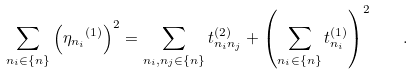Convert formula to latex. <formula><loc_0><loc_0><loc_500><loc_500>\sum _ { n _ { i } \in \{ n \} } { \left ( { \eta _ { n _ { i } } } ^ { ( 1 ) } \right ) ^ { 2 } } = \sum _ { n _ { i } , n _ { j } \in \{ n \} } { t _ { n _ { i } n _ { j } } ^ { ( 2 ) } } + \left ( \sum _ { n _ { i } \in \{ n \} } { t _ { n _ { i } } ^ { ( 1 ) } } \right ) ^ { 2 } \quad .</formula> 